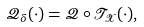<formula> <loc_0><loc_0><loc_500><loc_500>\mathcal { Q } _ { \delta } ( \cdot ) = \mathcal { Q } \circ \mathcal { T _ { X } } ( \cdot ) ,</formula> 